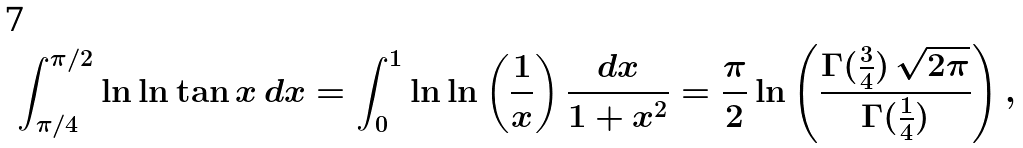<formula> <loc_0><loc_0><loc_500><loc_500>\int _ { \pi / 4 } ^ { \pi / 2 } \ln \ln \tan x \, d x = \int _ { 0 } ^ { 1 } \ln \ln \left ( \frac { 1 } { x } \right ) \frac { d x } { 1 + x ^ { 2 } } = \frac { \pi } { 2 } \ln \left ( \frac { \Gamma ( \frac { 3 } { 4 } ) \, \sqrt { 2 \pi } } { \Gamma ( \frac { 1 } { 4 } ) } \right ) ,</formula> 